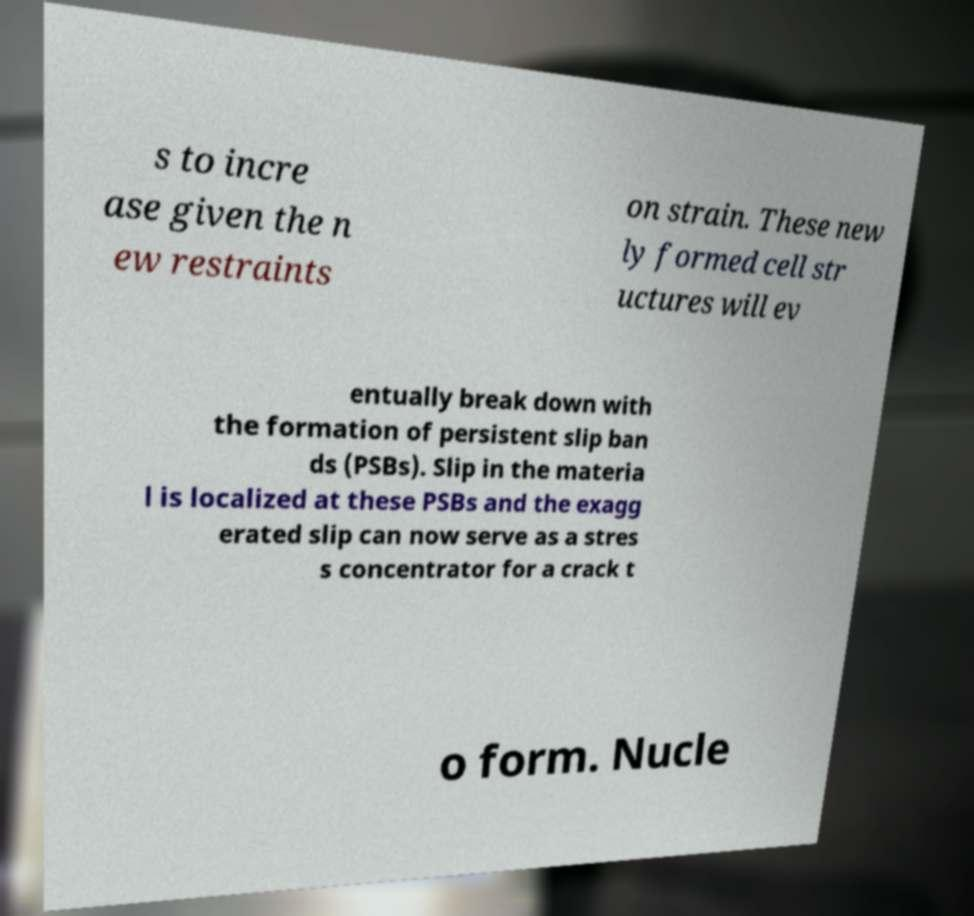Can you read and provide the text displayed in the image?This photo seems to have some interesting text. Can you extract and type it out for me? s to incre ase given the n ew restraints on strain. These new ly formed cell str uctures will ev entually break down with the formation of persistent slip ban ds (PSBs). Slip in the materia l is localized at these PSBs and the exagg erated slip can now serve as a stres s concentrator for a crack t o form. Nucle 